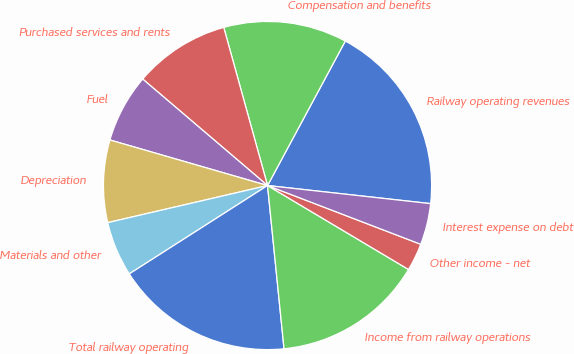Convert chart. <chart><loc_0><loc_0><loc_500><loc_500><pie_chart><fcel>Railway operating revenues<fcel>Compensation and benefits<fcel>Purchased services and rents<fcel>Fuel<fcel>Depreciation<fcel>Materials and other<fcel>Total railway operating<fcel>Income from railway operations<fcel>Other income - net<fcel>Interest expense on debt<nl><fcel>18.9%<fcel>12.16%<fcel>9.46%<fcel>6.76%<fcel>8.11%<fcel>5.42%<fcel>17.55%<fcel>14.85%<fcel>2.72%<fcel>4.07%<nl></chart> 